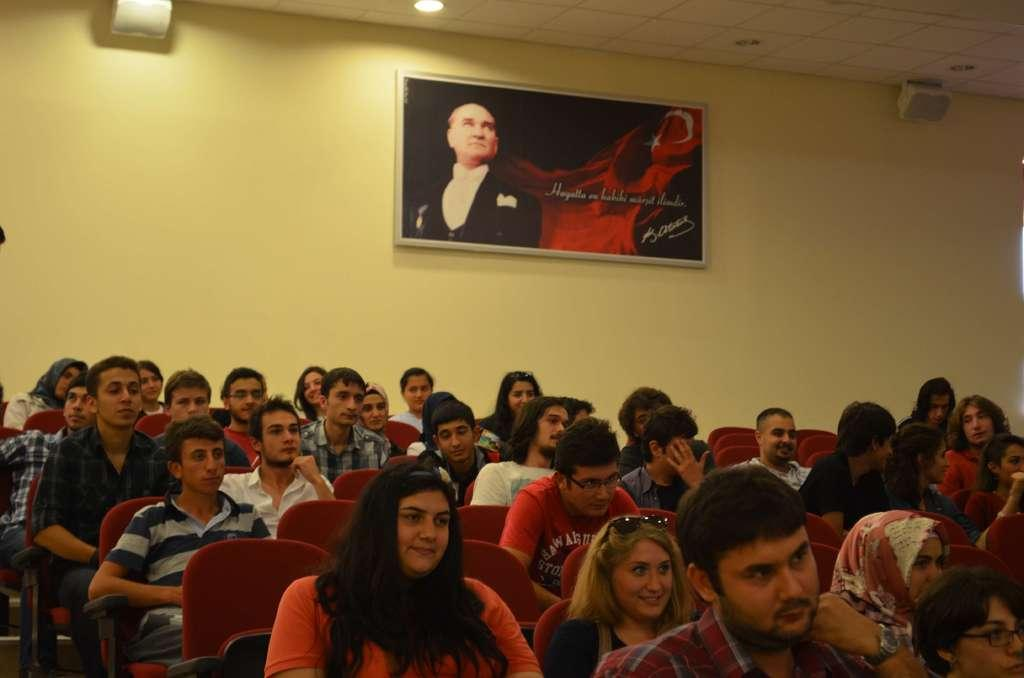What are the people in the image doing? There is a group of people sitting in the image. What can be seen on the wall in the background? There is a frame attached to the wall in the background. What color is the wall in the image? The wall is in yellow color. What can be seen providing illumination in the image? There are lights visible in the image. What type of bucket is being used to clean the pollution in the image? There is no bucket or pollution present in the image. 